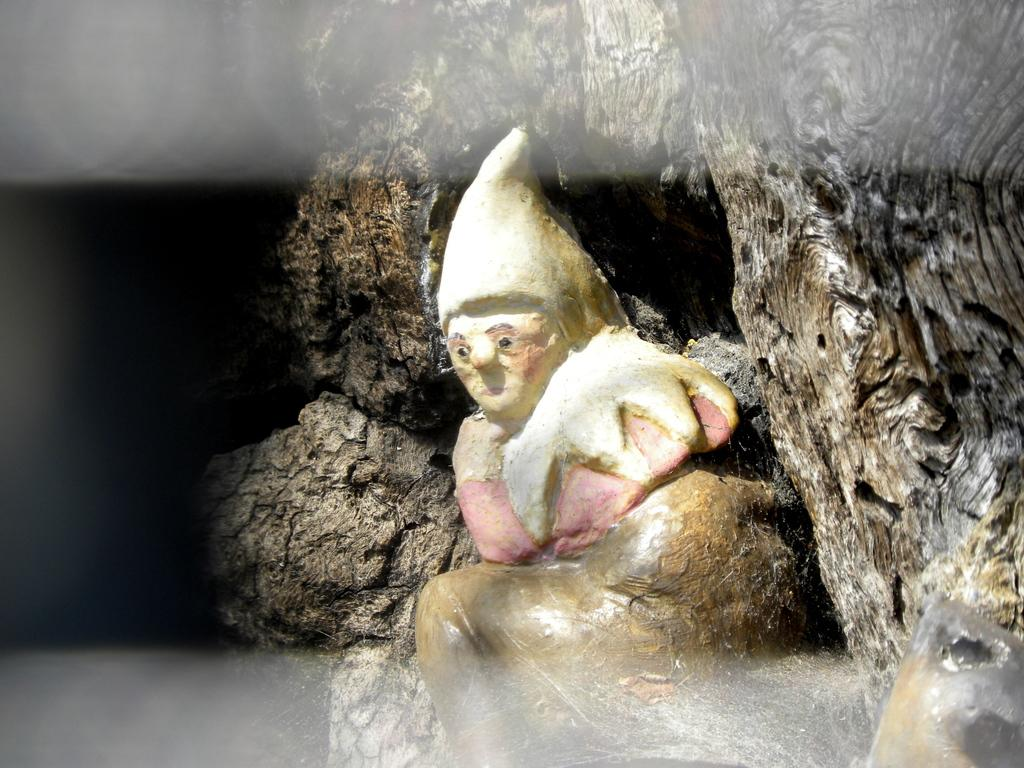What is the main subject in the center of the image? There is a statue in the image, and it is in the center of the image. Where is the statue located? The statue is on a rock. What type of food is being served in the lunchroom in the image? There is no lunchroom present in the image; it features a statue on a rock. Can you tell me how many people are saying good-bye in the image? There are no people present in the image, let alone any who might be saying good-bye. 